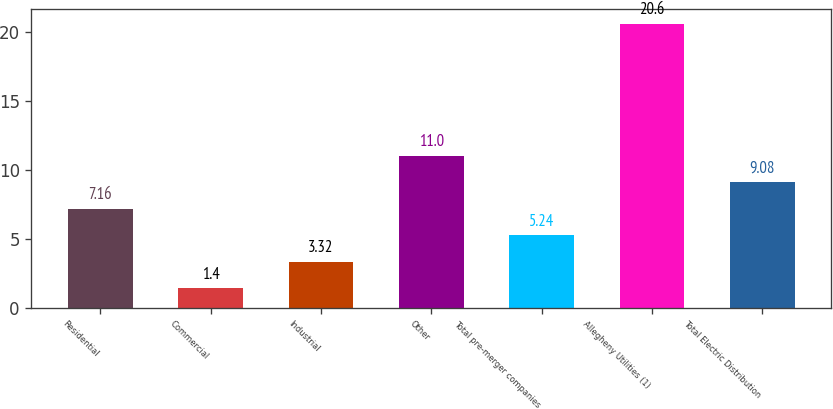<chart> <loc_0><loc_0><loc_500><loc_500><bar_chart><fcel>Residential<fcel>Commercial<fcel>Industrial<fcel>Other<fcel>Total pre-merger companies<fcel>Allegheny Utilities (1)<fcel>Total Electric Distribution<nl><fcel>7.16<fcel>1.4<fcel>3.32<fcel>11<fcel>5.24<fcel>20.6<fcel>9.08<nl></chart> 